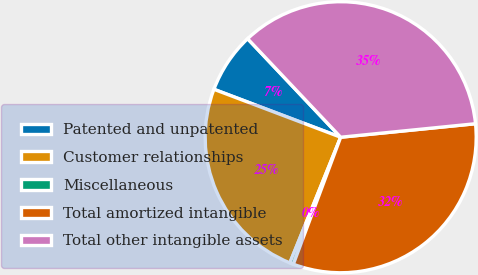Convert chart to OTSL. <chart><loc_0><loc_0><loc_500><loc_500><pie_chart><fcel>Patented and unpatented<fcel>Customer relationships<fcel>Miscellaneous<fcel>Total amortized intangible<fcel>Total other intangible assets<nl><fcel>7.2%<fcel>24.64%<fcel>0.44%<fcel>32.27%<fcel>35.46%<nl></chart> 